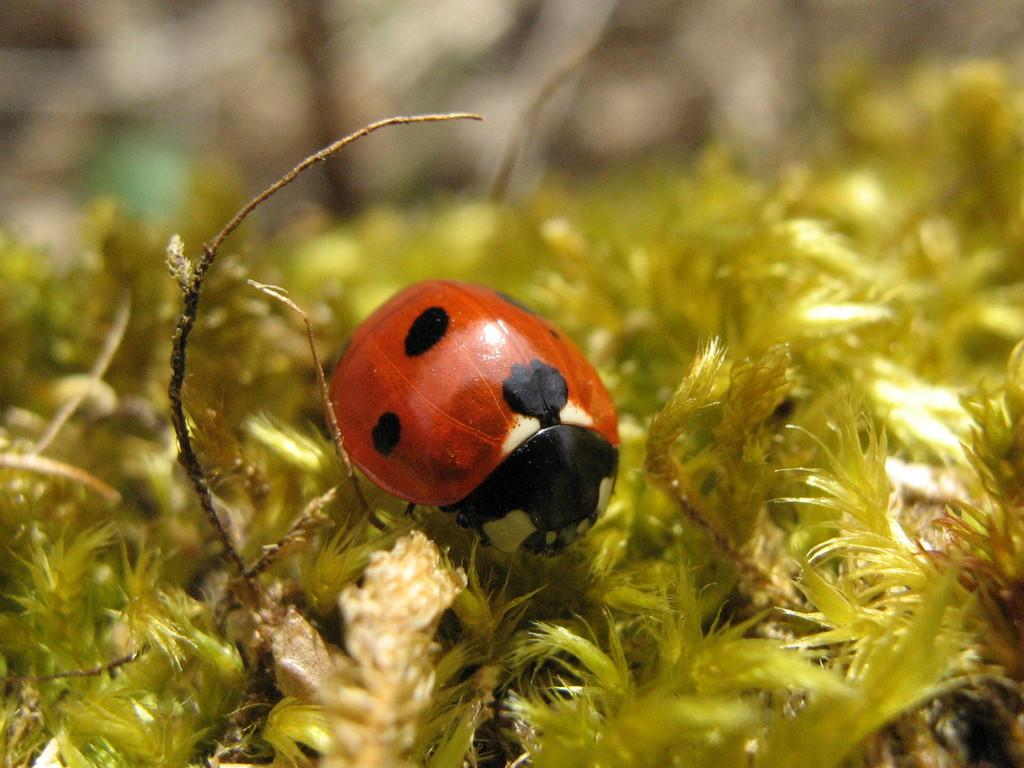What is the main subject in the middle of the image? There is an insect in the middle of the image. What type of vegetation can be seen in the image? There are green plants in the image. How many cherries are hanging from the coil in the image? There are no cherries or coils present in the image; it features an insect and green plants. 